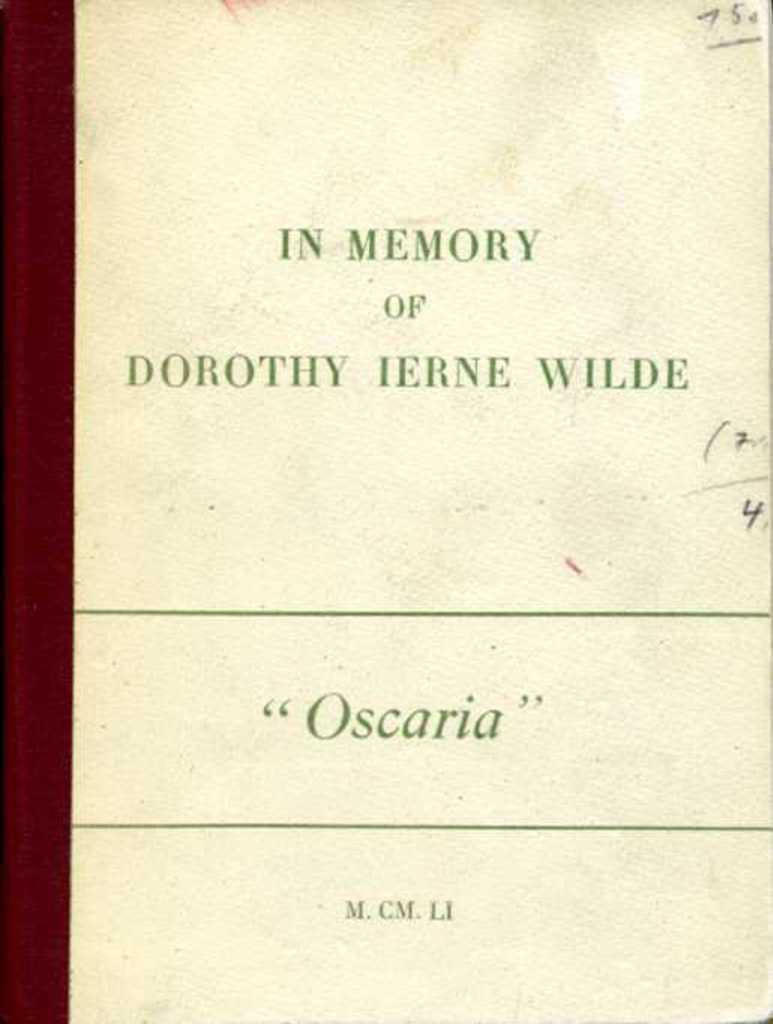Could you give a brief overview of what you see in this image? In the picture I can see an object which has something written on it. 